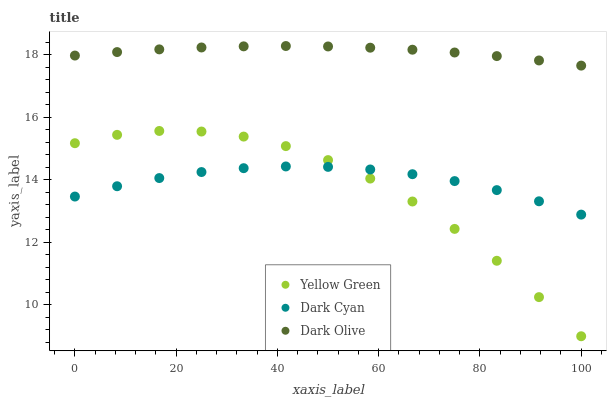Does Yellow Green have the minimum area under the curve?
Answer yes or no. Yes. Does Dark Olive have the maximum area under the curve?
Answer yes or no. Yes. Does Dark Olive have the minimum area under the curve?
Answer yes or no. No. Does Yellow Green have the maximum area under the curve?
Answer yes or no. No. Is Dark Olive the smoothest?
Answer yes or no. Yes. Is Yellow Green the roughest?
Answer yes or no. Yes. Is Yellow Green the smoothest?
Answer yes or no. No. Is Dark Olive the roughest?
Answer yes or no. No. Does Yellow Green have the lowest value?
Answer yes or no. Yes. Does Dark Olive have the lowest value?
Answer yes or no. No. Does Dark Olive have the highest value?
Answer yes or no. Yes. Does Yellow Green have the highest value?
Answer yes or no. No. Is Dark Cyan less than Dark Olive?
Answer yes or no. Yes. Is Dark Olive greater than Dark Cyan?
Answer yes or no. Yes. Does Dark Cyan intersect Yellow Green?
Answer yes or no. Yes. Is Dark Cyan less than Yellow Green?
Answer yes or no. No. Is Dark Cyan greater than Yellow Green?
Answer yes or no. No. Does Dark Cyan intersect Dark Olive?
Answer yes or no. No. 